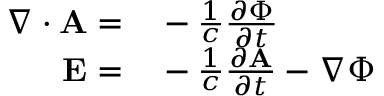<formula> <loc_0><loc_0><loc_500><loc_500>\begin{array} { r l } { \nabla \cdot A = } & - \frac { 1 } { c } \frac { \partial \Phi } { \partial t } } \\ { E = } & - \frac { 1 } { c } \frac { \partial A } { \partial t } - \nabla \Phi } \end{array}</formula> 